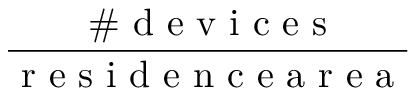<formula> <loc_0><loc_0><loc_500><loc_500>\frac { \# d e v i c e s } { r e s i d e n c e a r e a }</formula> 